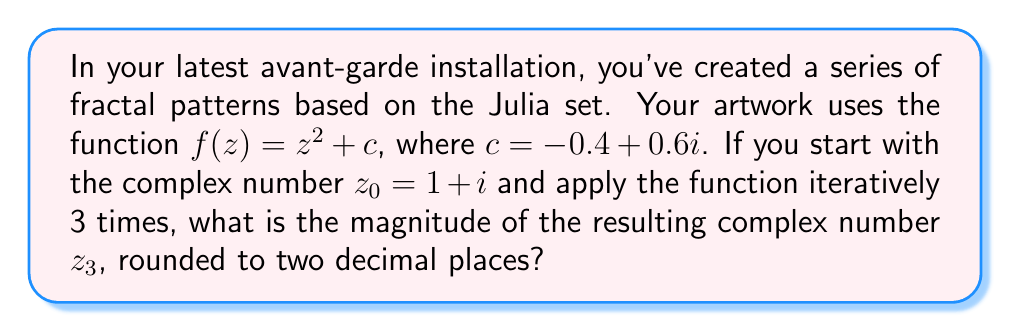Teach me how to tackle this problem. Let's iterate the function $f(z) = z^2 + c$ three times, starting with $z_0 = 1 + i$:

1) First iteration:
   $z_1 = f(z_0) = (1+i)^2 + (-0.4+0.6i)$
   $= (1^2 - i^2 + 2i) + (-0.4+0.6i)$
   $= (1 - (-1) + 2i) + (-0.4+0.6i)$
   $= 2 + 2i - 0.4 + 0.6i$
   $= 1.6 + 2.6i$

2) Second iteration:
   $z_2 = f(z_1) = (1.6+2.6i)^2 + (-0.4+0.6i)$
   $= (1.6^2 - 2.6^2 + 2(1.6)(2.6)i) + (-0.4+0.6i)$
   $= (2.56 - 6.76 + 8.32i) + (-0.4+0.6i)$
   $= -4.2 + 8.32i - 0.4 + 0.6i$
   $= -4.6 + 8.92i$

3) Third iteration:
   $z_3 = f(z_2) = (-4.6+8.92i)^2 + (-0.4+0.6i)$
   $= ((-4.6)^2 - 8.92^2 + 2(-4.6)(8.92)i) + (-0.4+0.6i)$
   $= (21.16 - 79.5664 - 82.0864i) + (-0.4+0.6i)$
   $= -58.4064 - 82.0864i - 0.4 + 0.6i$
   $= -58.8064 - 81.4864i$

Now, to find the magnitude of $z_3$, we use the formula $|a+bi| = \sqrt{a^2 + b^2}$:

$|z_3| = \sqrt{(-58.8064)^2 + (-81.4864)^2}$
$= \sqrt{3458.1927 + 6640.0350}$
$= \sqrt{10098.2277}$
$\approx 100.49$

Rounding to two decimal places, we get 100.49.
Answer: 100.49 